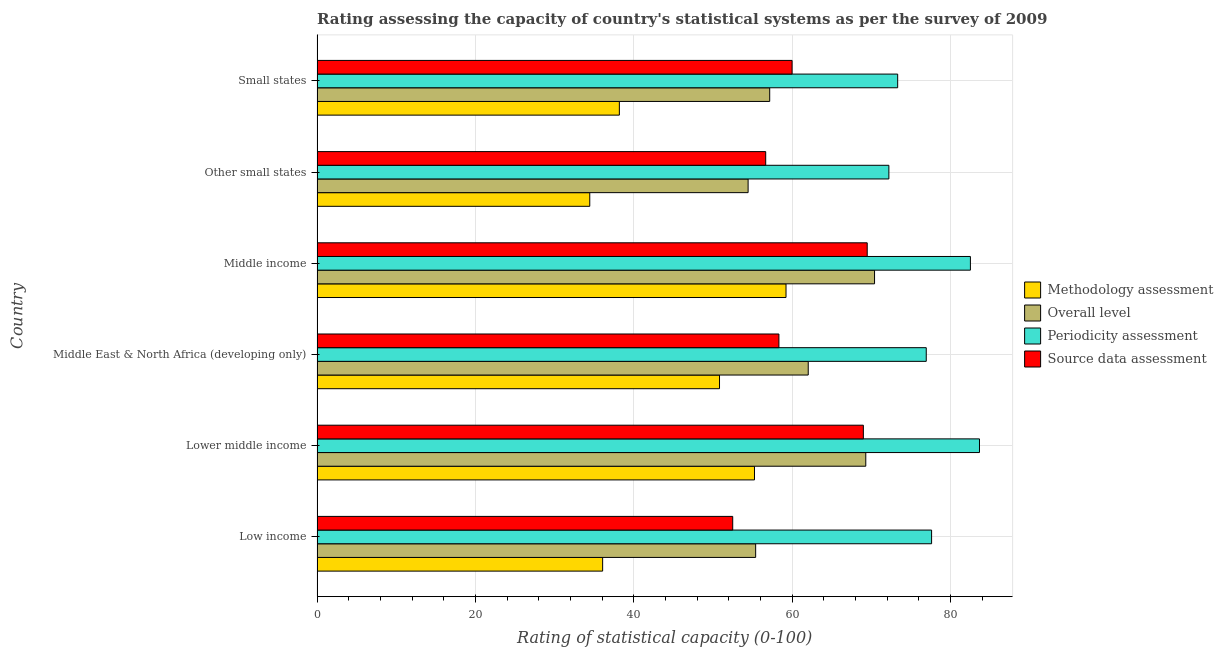How many different coloured bars are there?
Offer a terse response. 4. How many groups of bars are there?
Ensure brevity in your answer.  6. How many bars are there on the 5th tick from the top?
Your answer should be very brief. 4. How many bars are there on the 3rd tick from the bottom?
Provide a succinct answer. 4. In how many cases, is the number of bars for a given country not equal to the number of legend labels?
Give a very brief answer. 0. Across all countries, what is the maximum methodology assessment rating?
Keep it short and to the point. 59.23. Across all countries, what is the minimum source data assessment rating?
Keep it short and to the point. 52.5. In which country was the overall level rating maximum?
Provide a short and direct response. Middle income. In which country was the methodology assessment rating minimum?
Keep it short and to the point. Other small states. What is the total source data assessment rating in the graph?
Your answer should be very brief. 365.99. What is the difference between the overall level rating in Middle East & North Africa (developing only) and that in Other small states?
Give a very brief answer. 7.59. What is the difference between the methodology assessment rating in Small states and the overall level rating in Middle East & North Africa (developing only)?
Make the answer very short. -23.86. What is the average methodology assessment rating per country?
Give a very brief answer. 45.67. What is the difference between the periodicity assessment rating and source data assessment rating in Middle East & North Africa (developing only)?
Provide a succinct answer. 18.61. What is the ratio of the overall level rating in Middle income to that in Small states?
Provide a short and direct response. 1.23. Is the methodology assessment rating in Low income less than that in Other small states?
Provide a succinct answer. No. Is the difference between the source data assessment rating in Low income and Middle East & North Africa (developing only) greater than the difference between the periodicity assessment rating in Low income and Middle East & North Africa (developing only)?
Keep it short and to the point. No. What is the difference between the highest and the second highest source data assessment rating?
Your answer should be very brief. 0.49. What is the difference between the highest and the lowest overall level rating?
Your response must be concise. 15.97. Is the sum of the methodology assessment rating in Low income and Other small states greater than the maximum overall level rating across all countries?
Make the answer very short. Yes. Is it the case that in every country, the sum of the periodicity assessment rating and source data assessment rating is greater than the sum of overall level rating and methodology assessment rating?
Your response must be concise. No. What does the 2nd bar from the top in Middle income represents?
Make the answer very short. Periodicity assessment. What does the 4th bar from the bottom in Lower middle income represents?
Keep it short and to the point. Source data assessment. How many bars are there?
Your answer should be very brief. 24. How many countries are there in the graph?
Make the answer very short. 6. Are the values on the major ticks of X-axis written in scientific E-notation?
Offer a terse response. No. Does the graph contain grids?
Your answer should be compact. Yes. Where does the legend appear in the graph?
Give a very brief answer. Center right. How many legend labels are there?
Your response must be concise. 4. What is the title of the graph?
Ensure brevity in your answer.  Rating assessing the capacity of country's statistical systems as per the survey of 2009 . What is the label or title of the X-axis?
Provide a succinct answer. Rating of statistical capacity (0-100). What is the label or title of the Y-axis?
Ensure brevity in your answer.  Country. What is the Rating of statistical capacity (0-100) of Methodology assessment in Low income?
Your response must be concise. 36.07. What is the Rating of statistical capacity (0-100) in Overall level in Low income?
Provide a short and direct response. 55.4. What is the Rating of statistical capacity (0-100) in Periodicity assessment in Low income?
Your response must be concise. 77.62. What is the Rating of statistical capacity (0-100) of Source data assessment in Low income?
Offer a very short reply. 52.5. What is the Rating of statistical capacity (0-100) in Methodology assessment in Lower middle income?
Offer a terse response. 55.25. What is the Rating of statistical capacity (0-100) of Overall level in Lower middle income?
Give a very brief answer. 69.31. What is the Rating of statistical capacity (0-100) in Periodicity assessment in Lower middle income?
Offer a very short reply. 83.67. What is the Rating of statistical capacity (0-100) in Methodology assessment in Middle East & North Africa (developing only)?
Provide a short and direct response. 50.83. What is the Rating of statistical capacity (0-100) of Overall level in Middle East & North Africa (developing only)?
Ensure brevity in your answer.  62.04. What is the Rating of statistical capacity (0-100) of Periodicity assessment in Middle East & North Africa (developing only)?
Provide a short and direct response. 76.94. What is the Rating of statistical capacity (0-100) in Source data assessment in Middle East & North Africa (developing only)?
Your response must be concise. 58.33. What is the Rating of statistical capacity (0-100) of Methodology assessment in Middle income?
Your response must be concise. 59.23. What is the Rating of statistical capacity (0-100) of Overall level in Middle income?
Keep it short and to the point. 70.41. What is the Rating of statistical capacity (0-100) in Periodicity assessment in Middle income?
Your response must be concise. 82.52. What is the Rating of statistical capacity (0-100) in Source data assessment in Middle income?
Provide a short and direct response. 69.49. What is the Rating of statistical capacity (0-100) of Methodology assessment in Other small states?
Ensure brevity in your answer.  34.44. What is the Rating of statistical capacity (0-100) of Overall level in Other small states?
Provide a short and direct response. 54.44. What is the Rating of statistical capacity (0-100) in Periodicity assessment in Other small states?
Keep it short and to the point. 72.22. What is the Rating of statistical capacity (0-100) in Source data assessment in Other small states?
Offer a very short reply. 56.67. What is the Rating of statistical capacity (0-100) of Methodology assessment in Small states?
Ensure brevity in your answer.  38.18. What is the Rating of statistical capacity (0-100) of Overall level in Small states?
Give a very brief answer. 57.17. What is the Rating of statistical capacity (0-100) in Periodicity assessment in Small states?
Your answer should be very brief. 73.33. Across all countries, what is the maximum Rating of statistical capacity (0-100) in Methodology assessment?
Offer a terse response. 59.23. Across all countries, what is the maximum Rating of statistical capacity (0-100) in Overall level?
Your answer should be very brief. 70.41. Across all countries, what is the maximum Rating of statistical capacity (0-100) of Periodicity assessment?
Give a very brief answer. 83.67. Across all countries, what is the maximum Rating of statistical capacity (0-100) in Source data assessment?
Make the answer very short. 69.49. Across all countries, what is the minimum Rating of statistical capacity (0-100) in Methodology assessment?
Offer a terse response. 34.44. Across all countries, what is the minimum Rating of statistical capacity (0-100) of Overall level?
Provide a short and direct response. 54.44. Across all countries, what is the minimum Rating of statistical capacity (0-100) of Periodicity assessment?
Make the answer very short. 72.22. Across all countries, what is the minimum Rating of statistical capacity (0-100) in Source data assessment?
Offer a very short reply. 52.5. What is the total Rating of statistical capacity (0-100) in Methodology assessment in the graph?
Give a very brief answer. 274.01. What is the total Rating of statistical capacity (0-100) in Overall level in the graph?
Provide a succinct answer. 368.77. What is the total Rating of statistical capacity (0-100) of Periodicity assessment in the graph?
Your answer should be compact. 466.31. What is the total Rating of statistical capacity (0-100) in Source data assessment in the graph?
Your answer should be very brief. 365.99. What is the difference between the Rating of statistical capacity (0-100) of Methodology assessment in Low income and that in Lower middle income?
Give a very brief answer. -19.18. What is the difference between the Rating of statistical capacity (0-100) in Overall level in Low income and that in Lower middle income?
Your response must be concise. -13.91. What is the difference between the Rating of statistical capacity (0-100) of Periodicity assessment in Low income and that in Lower middle income?
Provide a short and direct response. -6.05. What is the difference between the Rating of statistical capacity (0-100) in Source data assessment in Low income and that in Lower middle income?
Provide a short and direct response. -16.5. What is the difference between the Rating of statistical capacity (0-100) in Methodology assessment in Low income and that in Middle East & North Africa (developing only)?
Provide a succinct answer. -14.76. What is the difference between the Rating of statistical capacity (0-100) of Overall level in Low income and that in Middle East & North Africa (developing only)?
Your response must be concise. -6.64. What is the difference between the Rating of statistical capacity (0-100) in Periodicity assessment in Low income and that in Middle East & North Africa (developing only)?
Your answer should be very brief. 0.67. What is the difference between the Rating of statistical capacity (0-100) in Source data assessment in Low income and that in Middle East & North Africa (developing only)?
Provide a succinct answer. -5.83. What is the difference between the Rating of statistical capacity (0-100) in Methodology assessment in Low income and that in Middle income?
Your answer should be compact. -23.16. What is the difference between the Rating of statistical capacity (0-100) in Overall level in Low income and that in Middle income?
Keep it short and to the point. -15.02. What is the difference between the Rating of statistical capacity (0-100) in Periodicity assessment in Low income and that in Middle income?
Your response must be concise. -4.9. What is the difference between the Rating of statistical capacity (0-100) in Source data assessment in Low income and that in Middle income?
Your answer should be very brief. -16.99. What is the difference between the Rating of statistical capacity (0-100) of Methodology assessment in Low income and that in Other small states?
Your answer should be compact. 1.63. What is the difference between the Rating of statistical capacity (0-100) of Periodicity assessment in Low income and that in Other small states?
Make the answer very short. 5.4. What is the difference between the Rating of statistical capacity (0-100) in Source data assessment in Low income and that in Other small states?
Ensure brevity in your answer.  -4.17. What is the difference between the Rating of statistical capacity (0-100) of Methodology assessment in Low income and that in Small states?
Provide a succinct answer. -2.11. What is the difference between the Rating of statistical capacity (0-100) of Overall level in Low income and that in Small states?
Your answer should be compact. -1.77. What is the difference between the Rating of statistical capacity (0-100) in Periodicity assessment in Low income and that in Small states?
Ensure brevity in your answer.  4.29. What is the difference between the Rating of statistical capacity (0-100) in Source data assessment in Low income and that in Small states?
Make the answer very short. -7.5. What is the difference between the Rating of statistical capacity (0-100) in Methodology assessment in Lower middle income and that in Middle East & North Africa (developing only)?
Provide a succinct answer. 4.42. What is the difference between the Rating of statistical capacity (0-100) of Overall level in Lower middle income and that in Middle East & North Africa (developing only)?
Ensure brevity in your answer.  7.27. What is the difference between the Rating of statistical capacity (0-100) of Periodicity assessment in Lower middle income and that in Middle East & North Africa (developing only)?
Your response must be concise. 6.72. What is the difference between the Rating of statistical capacity (0-100) in Source data assessment in Lower middle income and that in Middle East & North Africa (developing only)?
Make the answer very short. 10.67. What is the difference between the Rating of statistical capacity (0-100) in Methodology assessment in Lower middle income and that in Middle income?
Keep it short and to the point. -3.98. What is the difference between the Rating of statistical capacity (0-100) of Overall level in Lower middle income and that in Middle income?
Provide a short and direct response. -1.11. What is the difference between the Rating of statistical capacity (0-100) of Periodicity assessment in Lower middle income and that in Middle income?
Offer a very short reply. 1.15. What is the difference between the Rating of statistical capacity (0-100) of Source data assessment in Lower middle income and that in Middle income?
Your answer should be compact. -0.49. What is the difference between the Rating of statistical capacity (0-100) of Methodology assessment in Lower middle income and that in Other small states?
Make the answer very short. 20.81. What is the difference between the Rating of statistical capacity (0-100) in Overall level in Lower middle income and that in Other small states?
Provide a succinct answer. 14.86. What is the difference between the Rating of statistical capacity (0-100) in Periodicity assessment in Lower middle income and that in Other small states?
Offer a very short reply. 11.44. What is the difference between the Rating of statistical capacity (0-100) in Source data assessment in Lower middle income and that in Other small states?
Your answer should be compact. 12.33. What is the difference between the Rating of statistical capacity (0-100) in Methodology assessment in Lower middle income and that in Small states?
Keep it short and to the point. 17.07. What is the difference between the Rating of statistical capacity (0-100) in Overall level in Lower middle income and that in Small states?
Offer a terse response. 12.13. What is the difference between the Rating of statistical capacity (0-100) of Periodicity assessment in Lower middle income and that in Small states?
Make the answer very short. 10.33. What is the difference between the Rating of statistical capacity (0-100) of Methodology assessment in Middle East & North Africa (developing only) and that in Middle income?
Your answer should be compact. -8.4. What is the difference between the Rating of statistical capacity (0-100) of Overall level in Middle East & North Africa (developing only) and that in Middle income?
Offer a terse response. -8.38. What is the difference between the Rating of statistical capacity (0-100) in Periodicity assessment in Middle East & North Africa (developing only) and that in Middle income?
Offer a very short reply. -5.58. What is the difference between the Rating of statistical capacity (0-100) of Source data assessment in Middle East & North Africa (developing only) and that in Middle income?
Provide a succinct answer. -11.15. What is the difference between the Rating of statistical capacity (0-100) of Methodology assessment in Middle East & North Africa (developing only) and that in Other small states?
Provide a short and direct response. 16.39. What is the difference between the Rating of statistical capacity (0-100) in Overall level in Middle East & North Africa (developing only) and that in Other small states?
Your response must be concise. 7.59. What is the difference between the Rating of statistical capacity (0-100) of Periodicity assessment in Middle East & North Africa (developing only) and that in Other small states?
Offer a terse response. 4.72. What is the difference between the Rating of statistical capacity (0-100) of Source data assessment in Middle East & North Africa (developing only) and that in Other small states?
Your answer should be compact. 1.67. What is the difference between the Rating of statistical capacity (0-100) in Methodology assessment in Middle East & North Africa (developing only) and that in Small states?
Offer a terse response. 12.65. What is the difference between the Rating of statistical capacity (0-100) in Overall level in Middle East & North Africa (developing only) and that in Small states?
Give a very brief answer. 4.87. What is the difference between the Rating of statistical capacity (0-100) of Periodicity assessment in Middle East & North Africa (developing only) and that in Small states?
Your response must be concise. 3.61. What is the difference between the Rating of statistical capacity (0-100) of Source data assessment in Middle East & North Africa (developing only) and that in Small states?
Ensure brevity in your answer.  -1.67. What is the difference between the Rating of statistical capacity (0-100) of Methodology assessment in Middle income and that in Other small states?
Offer a terse response. 24.79. What is the difference between the Rating of statistical capacity (0-100) of Overall level in Middle income and that in Other small states?
Your answer should be very brief. 15.97. What is the difference between the Rating of statistical capacity (0-100) of Periodicity assessment in Middle income and that in Other small states?
Give a very brief answer. 10.3. What is the difference between the Rating of statistical capacity (0-100) in Source data assessment in Middle income and that in Other small states?
Make the answer very short. 12.82. What is the difference between the Rating of statistical capacity (0-100) in Methodology assessment in Middle income and that in Small states?
Your response must be concise. 21.05. What is the difference between the Rating of statistical capacity (0-100) of Overall level in Middle income and that in Small states?
Make the answer very short. 13.24. What is the difference between the Rating of statistical capacity (0-100) of Periodicity assessment in Middle income and that in Small states?
Your answer should be compact. 9.19. What is the difference between the Rating of statistical capacity (0-100) of Source data assessment in Middle income and that in Small states?
Ensure brevity in your answer.  9.49. What is the difference between the Rating of statistical capacity (0-100) of Methodology assessment in Other small states and that in Small states?
Provide a short and direct response. -3.74. What is the difference between the Rating of statistical capacity (0-100) of Overall level in Other small states and that in Small states?
Your answer should be compact. -2.73. What is the difference between the Rating of statistical capacity (0-100) in Periodicity assessment in Other small states and that in Small states?
Offer a terse response. -1.11. What is the difference between the Rating of statistical capacity (0-100) of Methodology assessment in Low income and the Rating of statistical capacity (0-100) of Overall level in Lower middle income?
Offer a terse response. -33.23. What is the difference between the Rating of statistical capacity (0-100) of Methodology assessment in Low income and the Rating of statistical capacity (0-100) of Periodicity assessment in Lower middle income?
Offer a terse response. -47.6. What is the difference between the Rating of statistical capacity (0-100) in Methodology assessment in Low income and the Rating of statistical capacity (0-100) in Source data assessment in Lower middle income?
Offer a very short reply. -32.93. What is the difference between the Rating of statistical capacity (0-100) in Overall level in Low income and the Rating of statistical capacity (0-100) in Periodicity assessment in Lower middle income?
Keep it short and to the point. -28.27. What is the difference between the Rating of statistical capacity (0-100) of Overall level in Low income and the Rating of statistical capacity (0-100) of Source data assessment in Lower middle income?
Provide a succinct answer. -13.6. What is the difference between the Rating of statistical capacity (0-100) in Periodicity assessment in Low income and the Rating of statistical capacity (0-100) in Source data assessment in Lower middle income?
Provide a short and direct response. 8.62. What is the difference between the Rating of statistical capacity (0-100) in Methodology assessment in Low income and the Rating of statistical capacity (0-100) in Overall level in Middle East & North Africa (developing only)?
Keep it short and to the point. -25.97. What is the difference between the Rating of statistical capacity (0-100) of Methodology assessment in Low income and the Rating of statistical capacity (0-100) of Periodicity assessment in Middle East & North Africa (developing only)?
Provide a succinct answer. -40.87. What is the difference between the Rating of statistical capacity (0-100) of Methodology assessment in Low income and the Rating of statistical capacity (0-100) of Source data assessment in Middle East & North Africa (developing only)?
Provide a succinct answer. -22.26. What is the difference between the Rating of statistical capacity (0-100) in Overall level in Low income and the Rating of statistical capacity (0-100) in Periodicity assessment in Middle East & North Africa (developing only)?
Make the answer very short. -21.55. What is the difference between the Rating of statistical capacity (0-100) of Overall level in Low income and the Rating of statistical capacity (0-100) of Source data assessment in Middle East & North Africa (developing only)?
Provide a short and direct response. -2.94. What is the difference between the Rating of statistical capacity (0-100) of Periodicity assessment in Low income and the Rating of statistical capacity (0-100) of Source data assessment in Middle East & North Africa (developing only)?
Provide a short and direct response. 19.29. What is the difference between the Rating of statistical capacity (0-100) of Methodology assessment in Low income and the Rating of statistical capacity (0-100) of Overall level in Middle income?
Provide a succinct answer. -34.34. What is the difference between the Rating of statistical capacity (0-100) of Methodology assessment in Low income and the Rating of statistical capacity (0-100) of Periodicity assessment in Middle income?
Offer a very short reply. -46.45. What is the difference between the Rating of statistical capacity (0-100) of Methodology assessment in Low income and the Rating of statistical capacity (0-100) of Source data assessment in Middle income?
Make the answer very short. -33.42. What is the difference between the Rating of statistical capacity (0-100) of Overall level in Low income and the Rating of statistical capacity (0-100) of Periodicity assessment in Middle income?
Ensure brevity in your answer.  -27.12. What is the difference between the Rating of statistical capacity (0-100) in Overall level in Low income and the Rating of statistical capacity (0-100) in Source data assessment in Middle income?
Make the answer very short. -14.09. What is the difference between the Rating of statistical capacity (0-100) in Periodicity assessment in Low income and the Rating of statistical capacity (0-100) in Source data assessment in Middle income?
Your answer should be compact. 8.13. What is the difference between the Rating of statistical capacity (0-100) of Methodology assessment in Low income and the Rating of statistical capacity (0-100) of Overall level in Other small states?
Your answer should be very brief. -18.37. What is the difference between the Rating of statistical capacity (0-100) of Methodology assessment in Low income and the Rating of statistical capacity (0-100) of Periodicity assessment in Other small states?
Make the answer very short. -36.15. What is the difference between the Rating of statistical capacity (0-100) of Methodology assessment in Low income and the Rating of statistical capacity (0-100) of Source data assessment in Other small states?
Your answer should be very brief. -20.6. What is the difference between the Rating of statistical capacity (0-100) of Overall level in Low income and the Rating of statistical capacity (0-100) of Periodicity assessment in Other small states?
Provide a succinct answer. -16.83. What is the difference between the Rating of statistical capacity (0-100) of Overall level in Low income and the Rating of statistical capacity (0-100) of Source data assessment in Other small states?
Provide a succinct answer. -1.27. What is the difference between the Rating of statistical capacity (0-100) of Periodicity assessment in Low income and the Rating of statistical capacity (0-100) of Source data assessment in Other small states?
Ensure brevity in your answer.  20.95. What is the difference between the Rating of statistical capacity (0-100) of Methodology assessment in Low income and the Rating of statistical capacity (0-100) of Overall level in Small states?
Offer a terse response. -21.1. What is the difference between the Rating of statistical capacity (0-100) of Methodology assessment in Low income and the Rating of statistical capacity (0-100) of Periodicity assessment in Small states?
Make the answer very short. -37.26. What is the difference between the Rating of statistical capacity (0-100) of Methodology assessment in Low income and the Rating of statistical capacity (0-100) of Source data assessment in Small states?
Offer a terse response. -23.93. What is the difference between the Rating of statistical capacity (0-100) in Overall level in Low income and the Rating of statistical capacity (0-100) in Periodicity assessment in Small states?
Provide a short and direct response. -17.94. What is the difference between the Rating of statistical capacity (0-100) in Overall level in Low income and the Rating of statistical capacity (0-100) in Source data assessment in Small states?
Your response must be concise. -4.6. What is the difference between the Rating of statistical capacity (0-100) of Periodicity assessment in Low income and the Rating of statistical capacity (0-100) of Source data assessment in Small states?
Keep it short and to the point. 17.62. What is the difference between the Rating of statistical capacity (0-100) in Methodology assessment in Lower middle income and the Rating of statistical capacity (0-100) in Overall level in Middle East & North Africa (developing only)?
Your answer should be very brief. -6.79. What is the difference between the Rating of statistical capacity (0-100) of Methodology assessment in Lower middle income and the Rating of statistical capacity (0-100) of Periodicity assessment in Middle East & North Africa (developing only)?
Your answer should be compact. -21.69. What is the difference between the Rating of statistical capacity (0-100) in Methodology assessment in Lower middle income and the Rating of statistical capacity (0-100) in Source data assessment in Middle East & North Africa (developing only)?
Offer a very short reply. -3.08. What is the difference between the Rating of statistical capacity (0-100) in Overall level in Lower middle income and the Rating of statistical capacity (0-100) in Periodicity assessment in Middle East & North Africa (developing only)?
Give a very brief answer. -7.64. What is the difference between the Rating of statistical capacity (0-100) of Overall level in Lower middle income and the Rating of statistical capacity (0-100) of Source data assessment in Middle East & North Africa (developing only)?
Your answer should be compact. 10.97. What is the difference between the Rating of statistical capacity (0-100) of Periodicity assessment in Lower middle income and the Rating of statistical capacity (0-100) of Source data assessment in Middle East & North Africa (developing only)?
Ensure brevity in your answer.  25.33. What is the difference between the Rating of statistical capacity (0-100) of Methodology assessment in Lower middle income and the Rating of statistical capacity (0-100) of Overall level in Middle income?
Offer a very short reply. -15.16. What is the difference between the Rating of statistical capacity (0-100) of Methodology assessment in Lower middle income and the Rating of statistical capacity (0-100) of Periodicity assessment in Middle income?
Provide a short and direct response. -27.27. What is the difference between the Rating of statistical capacity (0-100) in Methodology assessment in Lower middle income and the Rating of statistical capacity (0-100) in Source data assessment in Middle income?
Give a very brief answer. -14.24. What is the difference between the Rating of statistical capacity (0-100) in Overall level in Lower middle income and the Rating of statistical capacity (0-100) in Periodicity assessment in Middle income?
Your response must be concise. -13.22. What is the difference between the Rating of statistical capacity (0-100) of Overall level in Lower middle income and the Rating of statistical capacity (0-100) of Source data assessment in Middle income?
Your answer should be very brief. -0.18. What is the difference between the Rating of statistical capacity (0-100) of Periodicity assessment in Lower middle income and the Rating of statistical capacity (0-100) of Source data assessment in Middle income?
Your answer should be very brief. 14.18. What is the difference between the Rating of statistical capacity (0-100) in Methodology assessment in Lower middle income and the Rating of statistical capacity (0-100) in Overall level in Other small states?
Offer a very short reply. 0.81. What is the difference between the Rating of statistical capacity (0-100) in Methodology assessment in Lower middle income and the Rating of statistical capacity (0-100) in Periodicity assessment in Other small states?
Offer a very short reply. -16.97. What is the difference between the Rating of statistical capacity (0-100) of Methodology assessment in Lower middle income and the Rating of statistical capacity (0-100) of Source data assessment in Other small states?
Give a very brief answer. -1.42. What is the difference between the Rating of statistical capacity (0-100) of Overall level in Lower middle income and the Rating of statistical capacity (0-100) of Periodicity assessment in Other small states?
Offer a very short reply. -2.92. What is the difference between the Rating of statistical capacity (0-100) of Overall level in Lower middle income and the Rating of statistical capacity (0-100) of Source data assessment in Other small states?
Provide a short and direct response. 12.64. What is the difference between the Rating of statistical capacity (0-100) in Periodicity assessment in Lower middle income and the Rating of statistical capacity (0-100) in Source data assessment in Other small states?
Make the answer very short. 27. What is the difference between the Rating of statistical capacity (0-100) of Methodology assessment in Lower middle income and the Rating of statistical capacity (0-100) of Overall level in Small states?
Provide a succinct answer. -1.92. What is the difference between the Rating of statistical capacity (0-100) in Methodology assessment in Lower middle income and the Rating of statistical capacity (0-100) in Periodicity assessment in Small states?
Your answer should be compact. -18.08. What is the difference between the Rating of statistical capacity (0-100) of Methodology assessment in Lower middle income and the Rating of statistical capacity (0-100) of Source data assessment in Small states?
Offer a terse response. -4.75. What is the difference between the Rating of statistical capacity (0-100) of Overall level in Lower middle income and the Rating of statistical capacity (0-100) of Periodicity assessment in Small states?
Provide a short and direct response. -4.03. What is the difference between the Rating of statistical capacity (0-100) of Overall level in Lower middle income and the Rating of statistical capacity (0-100) of Source data assessment in Small states?
Give a very brief answer. 9.31. What is the difference between the Rating of statistical capacity (0-100) of Periodicity assessment in Lower middle income and the Rating of statistical capacity (0-100) of Source data assessment in Small states?
Give a very brief answer. 23.67. What is the difference between the Rating of statistical capacity (0-100) of Methodology assessment in Middle East & North Africa (developing only) and the Rating of statistical capacity (0-100) of Overall level in Middle income?
Keep it short and to the point. -19.58. What is the difference between the Rating of statistical capacity (0-100) of Methodology assessment in Middle East & North Africa (developing only) and the Rating of statistical capacity (0-100) of Periodicity assessment in Middle income?
Provide a succinct answer. -31.69. What is the difference between the Rating of statistical capacity (0-100) of Methodology assessment in Middle East & North Africa (developing only) and the Rating of statistical capacity (0-100) of Source data assessment in Middle income?
Keep it short and to the point. -18.65. What is the difference between the Rating of statistical capacity (0-100) in Overall level in Middle East & North Africa (developing only) and the Rating of statistical capacity (0-100) in Periodicity assessment in Middle income?
Keep it short and to the point. -20.48. What is the difference between the Rating of statistical capacity (0-100) in Overall level in Middle East & North Africa (developing only) and the Rating of statistical capacity (0-100) in Source data assessment in Middle income?
Your response must be concise. -7.45. What is the difference between the Rating of statistical capacity (0-100) of Periodicity assessment in Middle East & North Africa (developing only) and the Rating of statistical capacity (0-100) of Source data assessment in Middle income?
Provide a succinct answer. 7.46. What is the difference between the Rating of statistical capacity (0-100) in Methodology assessment in Middle East & North Africa (developing only) and the Rating of statistical capacity (0-100) in Overall level in Other small states?
Ensure brevity in your answer.  -3.61. What is the difference between the Rating of statistical capacity (0-100) in Methodology assessment in Middle East & North Africa (developing only) and the Rating of statistical capacity (0-100) in Periodicity assessment in Other small states?
Offer a terse response. -21.39. What is the difference between the Rating of statistical capacity (0-100) of Methodology assessment in Middle East & North Africa (developing only) and the Rating of statistical capacity (0-100) of Source data assessment in Other small states?
Provide a succinct answer. -5.83. What is the difference between the Rating of statistical capacity (0-100) in Overall level in Middle East & North Africa (developing only) and the Rating of statistical capacity (0-100) in Periodicity assessment in Other small states?
Your response must be concise. -10.19. What is the difference between the Rating of statistical capacity (0-100) of Overall level in Middle East & North Africa (developing only) and the Rating of statistical capacity (0-100) of Source data assessment in Other small states?
Make the answer very short. 5.37. What is the difference between the Rating of statistical capacity (0-100) of Periodicity assessment in Middle East & North Africa (developing only) and the Rating of statistical capacity (0-100) of Source data assessment in Other small states?
Give a very brief answer. 20.28. What is the difference between the Rating of statistical capacity (0-100) of Methodology assessment in Middle East & North Africa (developing only) and the Rating of statistical capacity (0-100) of Overall level in Small states?
Provide a succinct answer. -6.34. What is the difference between the Rating of statistical capacity (0-100) in Methodology assessment in Middle East & North Africa (developing only) and the Rating of statistical capacity (0-100) in Periodicity assessment in Small states?
Offer a very short reply. -22.5. What is the difference between the Rating of statistical capacity (0-100) of Methodology assessment in Middle East & North Africa (developing only) and the Rating of statistical capacity (0-100) of Source data assessment in Small states?
Give a very brief answer. -9.17. What is the difference between the Rating of statistical capacity (0-100) of Overall level in Middle East & North Africa (developing only) and the Rating of statistical capacity (0-100) of Periodicity assessment in Small states?
Your response must be concise. -11.3. What is the difference between the Rating of statistical capacity (0-100) of Overall level in Middle East & North Africa (developing only) and the Rating of statistical capacity (0-100) of Source data assessment in Small states?
Offer a very short reply. 2.04. What is the difference between the Rating of statistical capacity (0-100) in Periodicity assessment in Middle East & North Africa (developing only) and the Rating of statistical capacity (0-100) in Source data assessment in Small states?
Give a very brief answer. 16.94. What is the difference between the Rating of statistical capacity (0-100) of Methodology assessment in Middle income and the Rating of statistical capacity (0-100) of Overall level in Other small states?
Offer a terse response. 4.79. What is the difference between the Rating of statistical capacity (0-100) in Methodology assessment in Middle income and the Rating of statistical capacity (0-100) in Periodicity assessment in Other small states?
Offer a very short reply. -12.99. What is the difference between the Rating of statistical capacity (0-100) of Methodology assessment in Middle income and the Rating of statistical capacity (0-100) of Source data assessment in Other small states?
Your answer should be very brief. 2.56. What is the difference between the Rating of statistical capacity (0-100) in Overall level in Middle income and the Rating of statistical capacity (0-100) in Periodicity assessment in Other small states?
Keep it short and to the point. -1.81. What is the difference between the Rating of statistical capacity (0-100) in Overall level in Middle income and the Rating of statistical capacity (0-100) in Source data assessment in Other small states?
Offer a terse response. 13.75. What is the difference between the Rating of statistical capacity (0-100) in Periodicity assessment in Middle income and the Rating of statistical capacity (0-100) in Source data assessment in Other small states?
Keep it short and to the point. 25.85. What is the difference between the Rating of statistical capacity (0-100) of Methodology assessment in Middle income and the Rating of statistical capacity (0-100) of Overall level in Small states?
Offer a very short reply. 2.06. What is the difference between the Rating of statistical capacity (0-100) of Methodology assessment in Middle income and the Rating of statistical capacity (0-100) of Periodicity assessment in Small states?
Provide a short and direct response. -14.1. What is the difference between the Rating of statistical capacity (0-100) of Methodology assessment in Middle income and the Rating of statistical capacity (0-100) of Source data assessment in Small states?
Offer a terse response. -0.77. What is the difference between the Rating of statistical capacity (0-100) in Overall level in Middle income and the Rating of statistical capacity (0-100) in Periodicity assessment in Small states?
Provide a succinct answer. -2.92. What is the difference between the Rating of statistical capacity (0-100) in Overall level in Middle income and the Rating of statistical capacity (0-100) in Source data assessment in Small states?
Your answer should be compact. 10.41. What is the difference between the Rating of statistical capacity (0-100) in Periodicity assessment in Middle income and the Rating of statistical capacity (0-100) in Source data assessment in Small states?
Offer a very short reply. 22.52. What is the difference between the Rating of statistical capacity (0-100) of Methodology assessment in Other small states and the Rating of statistical capacity (0-100) of Overall level in Small states?
Your answer should be compact. -22.73. What is the difference between the Rating of statistical capacity (0-100) in Methodology assessment in Other small states and the Rating of statistical capacity (0-100) in Periodicity assessment in Small states?
Offer a terse response. -38.89. What is the difference between the Rating of statistical capacity (0-100) in Methodology assessment in Other small states and the Rating of statistical capacity (0-100) in Source data assessment in Small states?
Keep it short and to the point. -25.56. What is the difference between the Rating of statistical capacity (0-100) in Overall level in Other small states and the Rating of statistical capacity (0-100) in Periodicity assessment in Small states?
Provide a succinct answer. -18.89. What is the difference between the Rating of statistical capacity (0-100) of Overall level in Other small states and the Rating of statistical capacity (0-100) of Source data assessment in Small states?
Provide a short and direct response. -5.56. What is the difference between the Rating of statistical capacity (0-100) of Periodicity assessment in Other small states and the Rating of statistical capacity (0-100) of Source data assessment in Small states?
Provide a short and direct response. 12.22. What is the average Rating of statistical capacity (0-100) in Methodology assessment per country?
Your answer should be compact. 45.67. What is the average Rating of statistical capacity (0-100) of Overall level per country?
Your response must be concise. 61.46. What is the average Rating of statistical capacity (0-100) in Periodicity assessment per country?
Provide a short and direct response. 77.72. What is the average Rating of statistical capacity (0-100) of Source data assessment per country?
Make the answer very short. 61. What is the difference between the Rating of statistical capacity (0-100) of Methodology assessment and Rating of statistical capacity (0-100) of Overall level in Low income?
Provide a succinct answer. -19.33. What is the difference between the Rating of statistical capacity (0-100) of Methodology assessment and Rating of statistical capacity (0-100) of Periodicity assessment in Low income?
Provide a succinct answer. -41.55. What is the difference between the Rating of statistical capacity (0-100) in Methodology assessment and Rating of statistical capacity (0-100) in Source data assessment in Low income?
Provide a succinct answer. -16.43. What is the difference between the Rating of statistical capacity (0-100) of Overall level and Rating of statistical capacity (0-100) of Periodicity assessment in Low income?
Make the answer very short. -22.22. What is the difference between the Rating of statistical capacity (0-100) of Overall level and Rating of statistical capacity (0-100) of Source data assessment in Low income?
Give a very brief answer. 2.9. What is the difference between the Rating of statistical capacity (0-100) of Periodicity assessment and Rating of statistical capacity (0-100) of Source data assessment in Low income?
Your answer should be compact. 25.12. What is the difference between the Rating of statistical capacity (0-100) of Methodology assessment and Rating of statistical capacity (0-100) of Overall level in Lower middle income?
Your answer should be very brief. -14.06. What is the difference between the Rating of statistical capacity (0-100) in Methodology assessment and Rating of statistical capacity (0-100) in Periodicity assessment in Lower middle income?
Provide a short and direct response. -28.42. What is the difference between the Rating of statistical capacity (0-100) in Methodology assessment and Rating of statistical capacity (0-100) in Source data assessment in Lower middle income?
Provide a succinct answer. -13.75. What is the difference between the Rating of statistical capacity (0-100) of Overall level and Rating of statistical capacity (0-100) of Periodicity assessment in Lower middle income?
Keep it short and to the point. -14.36. What is the difference between the Rating of statistical capacity (0-100) of Overall level and Rating of statistical capacity (0-100) of Source data assessment in Lower middle income?
Your answer should be compact. 0.31. What is the difference between the Rating of statistical capacity (0-100) of Periodicity assessment and Rating of statistical capacity (0-100) of Source data assessment in Lower middle income?
Your answer should be very brief. 14.67. What is the difference between the Rating of statistical capacity (0-100) in Methodology assessment and Rating of statistical capacity (0-100) in Overall level in Middle East & North Africa (developing only)?
Make the answer very short. -11.2. What is the difference between the Rating of statistical capacity (0-100) in Methodology assessment and Rating of statistical capacity (0-100) in Periodicity assessment in Middle East & North Africa (developing only)?
Give a very brief answer. -26.11. What is the difference between the Rating of statistical capacity (0-100) in Overall level and Rating of statistical capacity (0-100) in Periodicity assessment in Middle East & North Africa (developing only)?
Make the answer very short. -14.91. What is the difference between the Rating of statistical capacity (0-100) in Overall level and Rating of statistical capacity (0-100) in Source data assessment in Middle East & North Africa (developing only)?
Offer a terse response. 3.7. What is the difference between the Rating of statistical capacity (0-100) of Periodicity assessment and Rating of statistical capacity (0-100) of Source data assessment in Middle East & North Africa (developing only)?
Make the answer very short. 18.61. What is the difference between the Rating of statistical capacity (0-100) of Methodology assessment and Rating of statistical capacity (0-100) of Overall level in Middle income?
Your answer should be very brief. -11.18. What is the difference between the Rating of statistical capacity (0-100) in Methodology assessment and Rating of statistical capacity (0-100) in Periodicity assessment in Middle income?
Give a very brief answer. -23.29. What is the difference between the Rating of statistical capacity (0-100) in Methodology assessment and Rating of statistical capacity (0-100) in Source data assessment in Middle income?
Your response must be concise. -10.26. What is the difference between the Rating of statistical capacity (0-100) of Overall level and Rating of statistical capacity (0-100) of Periodicity assessment in Middle income?
Ensure brevity in your answer.  -12.11. What is the difference between the Rating of statistical capacity (0-100) in Overall level and Rating of statistical capacity (0-100) in Source data assessment in Middle income?
Offer a very short reply. 0.93. What is the difference between the Rating of statistical capacity (0-100) in Periodicity assessment and Rating of statistical capacity (0-100) in Source data assessment in Middle income?
Make the answer very short. 13.03. What is the difference between the Rating of statistical capacity (0-100) in Methodology assessment and Rating of statistical capacity (0-100) in Periodicity assessment in Other small states?
Ensure brevity in your answer.  -37.78. What is the difference between the Rating of statistical capacity (0-100) of Methodology assessment and Rating of statistical capacity (0-100) of Source data assessment in Other small states?
Your response must be concise. -22.22. What is the difference between the Rating of statistical capacity (0-100) in Overall level and Rating of statistical capacity (0-100) in Periodicity assessment in Other small states?
Offer a very short reply. -17.78. What is the difference between the Rating of statistical capacity (0-100) of Overall level and Rating of statistical capacity (0-100) of Source data assessment in Other small states?
Keep it short and to the point. -2.22. What is the difference between the Rating of statistical capacity (0-100) of Periodicity assessment and Rating of statistical capacity (0-100) of Source data assessment in Other small states?
Offer a terse response. 15.56. What is the difference between the Rating of statistical capacity (0-100) in Methodology assessment and Rating of statistical capacity (0-100) in Overall level in Small states?
Give a very brief answer. -18.99. What is the difference between the Rating of statistical capacity (0-100) of Methodology assessment and Rating of statistical capacity (0-100) of Periodicity assessment in Small states?
Your answer should be compact. -35.15. What is the difference between the Rating of statistical capacity (0-100) in Methodology assessment and Rating of statistical capacity (0-100) in Source data assessment in Small states?
Provide a short and direct response. -21.82. What is the difference between the Rating of statistical capacity (0-100) in Overall level and Rating of statistical capacity (0-100) in Periodicity assessment in Small states?
Provide a short and direct response. -16.16. What is the difference between the Rating of statistical capacity (0-100) of Overall level and Rating of statistical capacity (0-100) of Source data assessment in Small states?
Provide a succinct answer. -2.83. What is the difference between the Rating of statistical capacity (0-100) in Periodicity assessment and Rating of statistical capacity (0-100) in Source data assessment in Small states?
Your answer should be very brief. 13.33. What is the ratio of the Rating of statistical capacity (0-100) of Methodology assessment in Low income to that in Lower middle income?
Ensure brevity in your answer.  0.65. What is the ratio of the Rating of statistical capacity (0-100) in Overall level in Low income to that in Lower middle income?
Keep it short and to the point. 0.8. What is the ratio of the Rating of statistical capacity (0-100) of Periodicity assessment in Low income to that in Lower middle income?
Provide a succinct answer. 0.93. What is the ratio of the Rating of statistical capacity (0-100) of Source data assessment in Low income to that in Lower middle income?
Make the answer very short. 0.76. What is the ratio of the Rating of statistical capacity (0-100) in Methodology assessment in Low income to that in Middle East & North Africa (developing only)?
Your answer should be very brief. 0.71. What is the ratio of the Rating of statistical capacity (0-100) in Overall level in Low income to that in Middle East & North Africa (developing only)?
Your answer should be compact. 0.89. What is the ratio of the Rating of statistical capacity (0-100) in Periodicity assessment in Low income to that in Middle East & North Africa (developing only)?
Make the answer very short. 1.01. What is the ratio of the Rating of statistical capacity (0-100) in Source data assessment in Low income to that in Middle East & North Africa (developing only)?
Your answer should be compact. 0.9. What is the ratio of the Rating of statistical capacity (0-100) in Methodology assessment in Low income to that in Middle income?
Keep it short and to the point. 0.61. What is the ratio of the Rating of statistical capacity (0-100) in Overall level in Low income to that in Middle income?
Give a very brief answer. 0.79. What is the ratio of the Rating of statistical capacity (0-100) of Periodicity assessment in Low income to that in Middle income?
Provide a short and direct response. 0.94. What is the ratio of the Rating of statistical capacity (0-100) in Source data assessment in Low income to that in Middle income?
Your answer should be compact. 0.76. What is the ratio of the Rating of statistical capacity (0-100) of Methodology assessment in Low income to that in Other small states?
Ensure brevity in your answer.  1.05. What is the ratio of the Rating of statistical capacity (0-100) of Overall level in Low income to that in Other small states?
Your answer should be compact. 1.02. What is the ratio of the Rating of statistical capacity (0-100) in Periodicity assessment in Low income to that in Other small states?
Offer a terse response. 1.07. What is the ratio of the Rating of statistical capacity (0-100) in Source data assessment in Low income to that in Other small states?
Your answer should be very brief. 0.93. What is the ratio of the Rating of statistical capacity (0-100) of Methodology assessment in Low income to that in Small states?
Offer a very short reply. 0.94. What is the ratio of the Rating of statistical capacity (0-100) in Periodicity assessment in Low income to that in Small states?
Your response must be concise. 1.06. What is the ratio of the Rating of statistical capacity (0-100) in Methodology assessment in Lower middle income to that in Middle East & North Africa (developing only)?
Provide a short and direct response. 1.09. What is the ratio of the Rating of statistical capacity (0-100) in Overall level in Lower middle income to that in Middle East & North Africa (developing only)?
Provide a succinct answer. 1.12. What is the ratio of the Rating of statistical capacity (0-100) of Periodicity assessment in Lower middle income to that in Middle East & North Africa (developing only)?
Your answer should be compact. 1.09. What is the ratio of the Rating of statistical capacity (0-100) in Source data assessment in Lower middle income to that in Middle East & North Africa (developing only)?
Keep it short and to the point. 1.18. What is the ratio of the Rating of statistical capacity (0-100) in Methodology assessment in Lower middle income to that in Middle income?
Provide a succinct answer. 0.93. What is the ratio of the Rating of statistical capacity (0-100) in Overall level in Lower middle income to that in Middle income?
Ensure brevity in your answer.  0.98. What is the ratio of the Rating of statistical capacity (0-100) of Periodicity assessment in Lower middle income to that in Middle income?
Offer a very short reply. 1.01. What is the ratio of the Rating of statistical capacity (0-100) of Methodology assessment in Lower middle income to that in Other small states?
Keep it short and to the point. 1.6. What is the ratio of the Rating of statistical capacity (0-100) of Overall level in Lower middle income to that in Other small states?
Provide a short and direct response. 1.27. What is the ratio of the Rating of statistical capacity (0-100) of Periodicity assessment in Lower middle income to that in Other small states?
Offer a very short reply. 1.16. What is the ratio of the Rating of statistical capacity (0-100) in Source data assessment in Lower middle income to that in Other small states?
Your response must be concise. 1.22. What is the ratio of the Rating of statistical capacity (0-100) of Methodology assessment in Lower middle income to that in Small states?
Ensure brevity in your answer.  1.45. What is the ratio of the Rating of statistical capacity (0-100) in Overall level in Lower middle income to that in Small states?
Ensure brevity in your answer.  1.21. What is the ratio of the Rating of statistical capacity (0-100) in Periodicity assessment in Lower middle income to that in Small states?
Offer a terse response. 1.14. What is the ratio of the Rating of statistical capacity (0-100) in Source data assessment in Lower middle income to that in Small states?
Keep it short and to the point. 1.15. What is the ratio of the Rating of statistical capacity (0-100) in Methodology assessment in Middle East & North Africa (developing only) to that in Middle income?
Provide a short and direct response. 0.86. What is the ratio of the Rating of statistical capacity (0-100) in Overall level in Middle East & North Africa (developing only) to that in Middle income?
Offer a terse response. 0.88. What is the ratio of the Rating of statistical capacity (0-100) in Periodicity assessment in Middle East & North Africa (developing only) to that in Middle income?
Your answer should be very brief. 0.93. What is the ratio of the Rating of statistical capacity (0-100) in Source data assessment in Middle East & North Africa (developing only) to that in Middle income?
Your answer should be very brief. 0.84. What is the ratio of the Rating of statistical capacity (0-100) in Methodology assessment in Middle East & North Africa (developing only) to that in Other small states?
Provide a short and direct response. 1.48. What is the ratio of the Rating of statistical capacity (0-100) of Overall level in Middle East & North Africa (developing only) to that in Other small states?
Keep it short and to the point. 1.14. What is the ratio of the Rating of statistical capacity (0-100) of Periodicity assessment in Middle East & North Africa (developing only) to that in Other small states?
Provide a succinct answer. 1.07. What is the ratio of the Rating of statistical capacity (0-100) of Source data assessment in Middle East & North Africa (developing only) to that in Other small states?
Give a very brief answer. 1.03. What is the ratio of the Rating of statistical capacity (0-100) of Methodology assessment in Middle East & North Africa (developing only) to that in Small states?
Provide a short and direct response. 1.33. What is the ratio of the Rating of statistical capacity (0-100) in Overall level in Middle East & North Africa (developing only) to that in Small states?
Your answer should be very brief. 1.09. What is the ratio of the Rating of statistical capacity (0-100) of Periodicity assessment in Middle East & North Africa (developing only) to that in Small states?
Your response must be concise. 1.05. What is the ratio of the Rating of statistical capacity (0-100) of Source data assessment in Middle East & North Africa (developing only) to that in Small states?
Your answer should be compact. 0.97. What is the ratio of the Rating of statistical capacity (0-100) in Methodology assessment in Middle income to that in Other small states?
Offer a very short reply. 1.72. What is the ratio of the Rating of statistical capacity (0-100) in Overall level in Middle income to that in Other small states?
Give a very brief answer. 1.29. What is the ratio of the Rating of statistical capacity (0-100) in Periodicity assessment in Middle income to that in Other small states?
Provide a short and direct response. 1.14. What is the ratio of the Rating of statistical capacity (0-100) of Source data assessment in Middle income to that in Other small states?
Give a very brief answer. 1.23. What is the ratio of the Rating of statistical capacity (0-100) of Methodology assessment in Middle income to that in Small states?
Your answer should be very brief. 1.55. What is the ratio of the Rating of statistical capacity (0-100) of Overall level in Middle income to that in Small states?
Offer a terse response. 1.23. What is the ratio of the Rating of statistical capacity (0-100) of Periodicity assessment in Middle income to that in Small states?
Your answer should be compact. 1.13. What is the ratio of the Rating of statistical capacity (0-100) of Source data assessment in Middle income to that in Small states?
Keep it short and to the point. 1.16. What is the ratio of the Rating of statistical capacity (0-100) of Methodology assessment in Other small states to that in Small states?
Your response must be concise. 0.9. What is the ratio of the Rating of statistical capacity (0-100) of Overall level in Other small states to that in Small states?
Your answer should be very brief. 0.95. What is the ratio of the Rating of statistical capacity (0-100) in Source data assessment in Other small states to that in Small states?
Provide a succinct answer. 0.94. What is the difference between the highest and the second highest Rating of statistical capacity (0-100) of Methodology assessment?
Offer a very short reply. 3.98. What is the difference between the highest and the second highest Rating of statistical capacity (0-100) of Overall level?
Make the answer very short. 1.11. What is the difference between the highest and the second highest Rating of statistical capacity (0-100) of Periodicity assessment?
Offer a terse response. 1.15. What is the difference between the highest and the second highest Rating of statistical capacity (0-100) in Source data assessment?
Your response must be concise. 0.49. What is the difference between the highest and the lowest Rating of statistical capacity (0-100) of Methodology assessment?
Keep it short and to the point. 24.79. What is the difference between the highest and the lowest Rating of statistical capacity (0-100) of Overall level?
Your response must be concise. 15.97. What is the difference between the highest and the lowest Rating of statistical capacity (0-100) of Periodicity assessment?
Offer a terse response. 11.44. What is the difference between the highest and the lowest Rating of statistical capacity (0-100) of Source data assessment?
Your answer should be very brief. 16.99. 